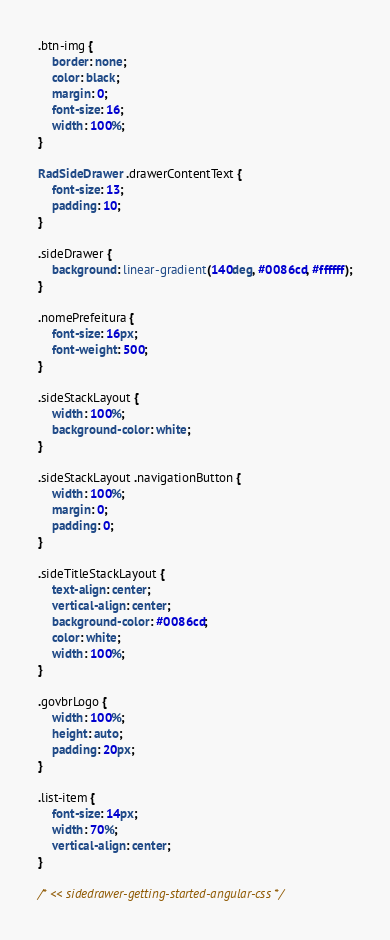<code> <loc_0><loc_0><loc_500><loc_500><_CSS_>.btn-img {
    border: none;
    color: black;
    margin: 0;
    font-size: 16;
    width: 100%;
}

RadSideDrawer .drawerContentText {
    font-size: 13;
    padding: 10;
}

.sideDrawer {
    background: linear-gradient(140deg, #0086cd, #ffffff);
}

.nomePrefeitura {
    font-size: 16px;
    font-weight: 500;
}

.sideStackLayout {
    width: 100%;
    background-color: white;
}

.sideStackLayout .navigationButton {
    width: 100%;
    margin: 0;
    padding: 0;
}

.sideTitleStackLayout {
    text-align: center;
    vertical-align: center;
    background-color: #0086cd;
    color: white;
    width: 100%;
}

.govbrLogo {
    width: 100%;
    height: auto;
    padding: 20px;
}

.list-item {
    font-size: 14px;
    width: 70%;
    vertical-align: center;
}

/* << sidedrawer-getting-started-angular-css */
</code> 